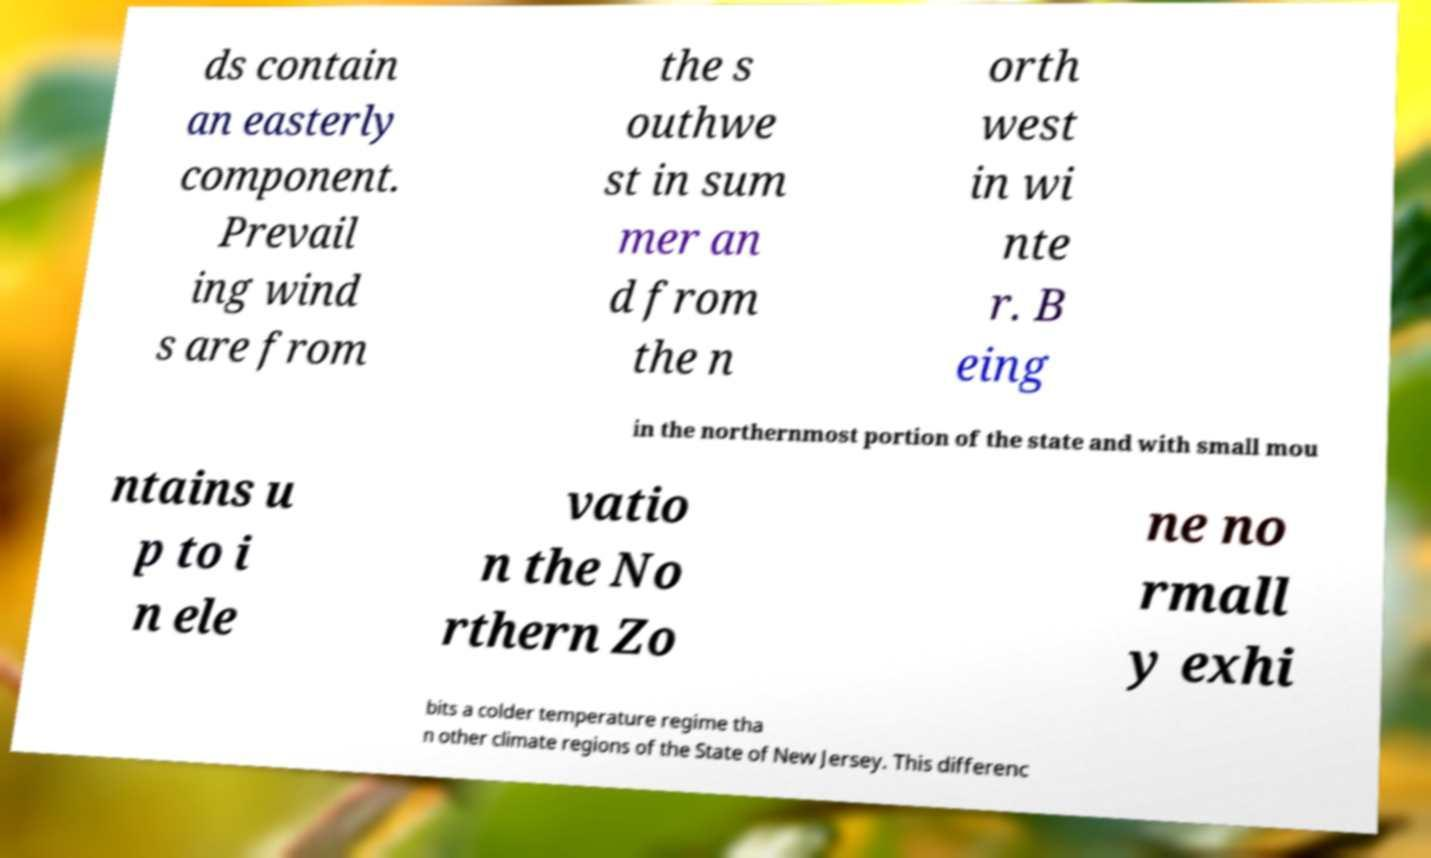I need the written content from this picture converted into text. Can you do that? ds contain an easterly component. Prevail ing wind s are from the s outhwe st in sum mer an d from the n orth west in wi nte r. B eing in the northernmost portion of the state and with small mou ntains u p to i n ele vatio n the No rthern Zo ne no rmall y exhi bits a colder temperature regime tha n other climate regions of the State of New Jersey. This differenc 